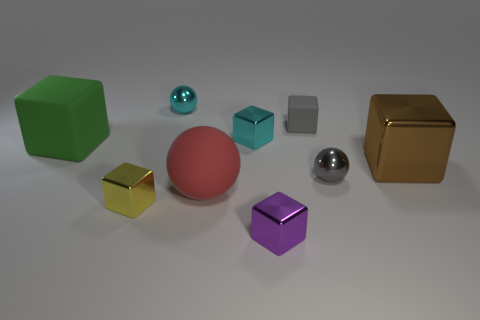Subtract 1 cubes. How many cubes are left? 5 Subtract all cyan blocks. How many blocks are left? 5 Subtract all cyan blocks. How many blocks are left? 5 Subtract all green blocks. Subtract all blue cylinders. How many blocks are left? 5 Add 1 purple shiny objects. How many objects exist? 10 Subtract all cubes. How many objects are left? 3 Subtract all brown shiny balls. Subtract all tiny gray rubber objects. How many objects are left? 8 Add 7 cyan shiny cubes. How many cyan shiny cubes are left? 8 Add 5 large brown metallic objects. How many large brown metallic objects exist? 6 Subtract 1 green blocks. How many objects are left? 8 